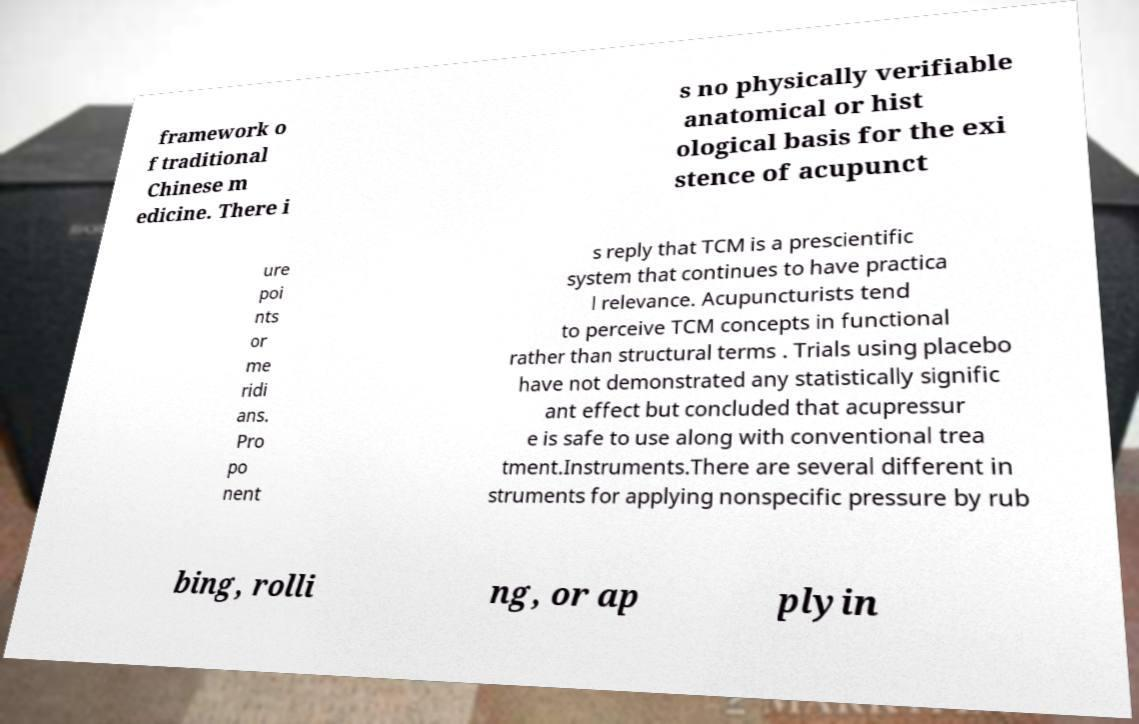There's text embedded in this image that I need extracted. Can you transcribe it verbatim? framework o f traditional Chinese m edicine. There i s no physically verifiable anatomical or hist ological basis for the exi stence of acupunct ure poi nts or me ridi ans. Pro po nent s reply that TCM is a prescientific system that continues to have practica l relevance. Acupuncturists tend to perceive TCM concepts in functional rather than structural terms . Trials using placebo have not demonstrated any statistically signific ant effect but concluded that acupressur e is safe to use along with conventional trea tment.Instruments.There are several different in struments for applying nonspecific pressure by rub bing, rolli ng, or ap plyin 